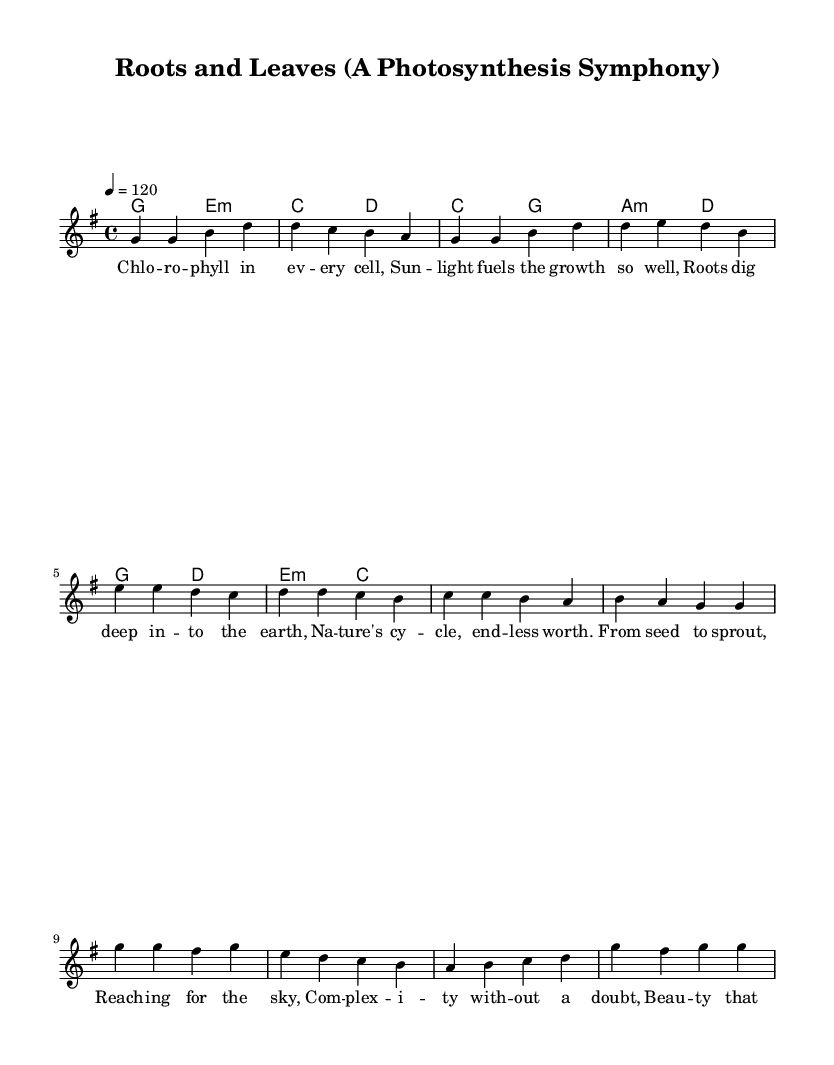What is the key signature of this music? The key signature is G major, which has one sharp (F#). This can be identified in the sheet music where the F# appears on the staff at the beginning.
Answer: G major What is the time signature of this music? The time signature is 4/4, which is indicated at the beginning of the score next to the key signature. This means there are four beats in each measure and a quarter note gets one beat.
Answer: 4/4 What is the tempo marking of this music? The tempo marking is indicated as "4 = 120", which means that there are 120 quarter note beats per minute. This is shown in the score near the top, specifying the speed of the music.
Answer: 120 How many measures are in the verse? The verse consists of 4 measures, as indicated by the division of bars in the melody line for the verse section. Each group of notes separated by vertical lines represents a measure, and there are four groups here.
Answer: 4 What is the primary theme of the lyrics? The primary theme of the lyrics revolves around the beauty and complexity of plant life and ecosystems, as described through the depiction of chlorophyll, roots, and nature's cycles throughout the verses and chorus.
Answer: Beauty and complexity of plant life Which part of the song features the lyrical lines "Roots and leaves, stems and flowers"? These lines are featured in the chorus, which is separate from the verse and pre-chorus sections. The structure of the song segments the lyrics accordingly, making the chorus distinct.
Answer: Chorus 